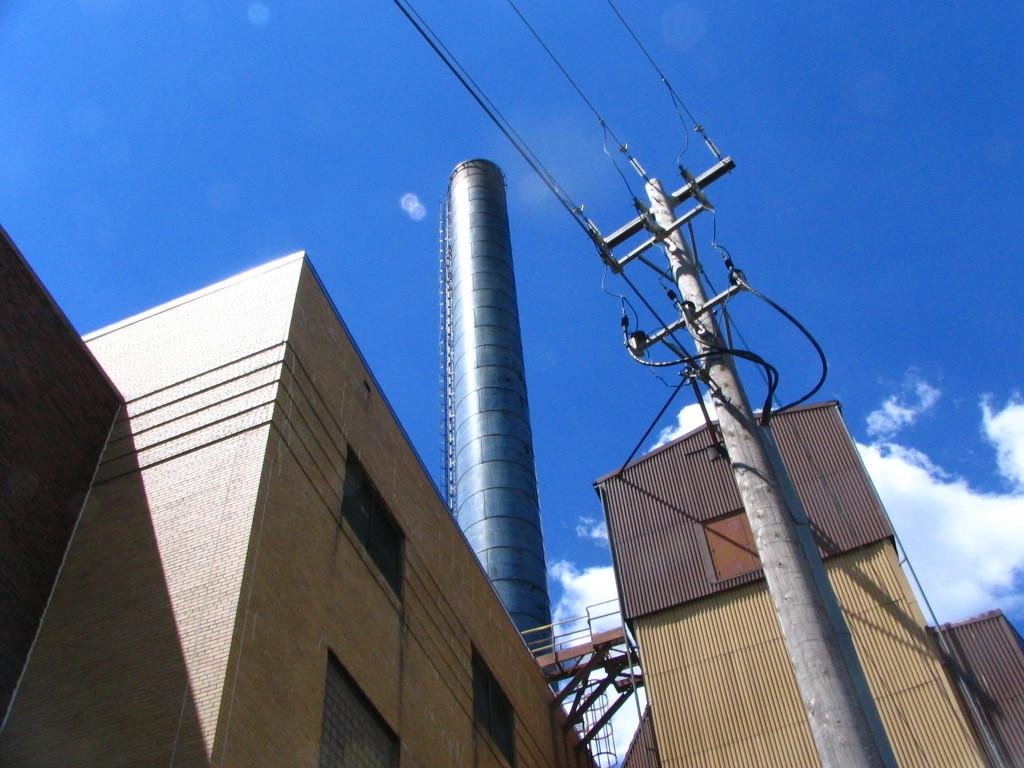What type of structures can be seen in the image? There are buildings in the image. What object is present in the foreground of the image? There is a pole in the image. What can be seen attached to the pole? There are lights in the image. What is visible in the background of the image? The sky is visible in the background of the image. What is the condition of the sky in the image? There are clouds in the sky. How many tomatoes are hanging from the pole in the image? There are no tomatoes present in the image. Who is the partner of the person standing next to the pole in the image? There is no person standing next to the pole in the image. 